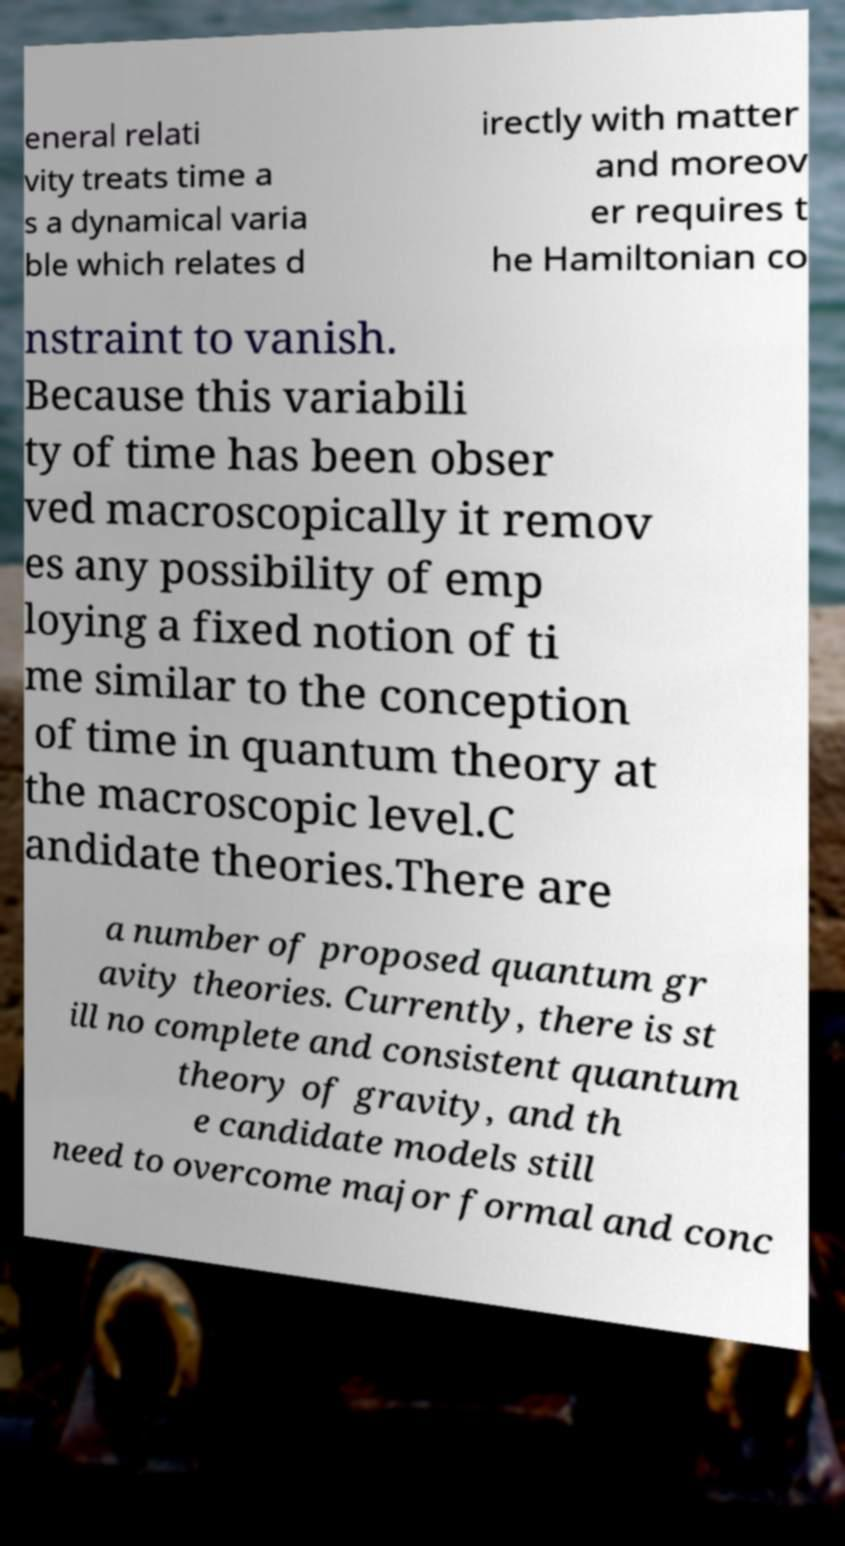What messages or text are displayed in this image? I need them in a readable, typed format. eneral relati vity treats time a s a dynamical varia ble which relates d irectly with matter and moreov er requires t he Hamiltonian co nstraint to vanish. Because this variabili ty of time has been obser ved macroscopically it remov es any possibility of emp loying a fixed notion of ti me similar to the conception of time in quantum theory at the macroscopic level.C andidate theories.There are a number of proposed quantum gr avity theories. Currently, there is st ill no complete and consistent quantum theory of gravity, and th e candidate models still need to overcome major formal and conc 